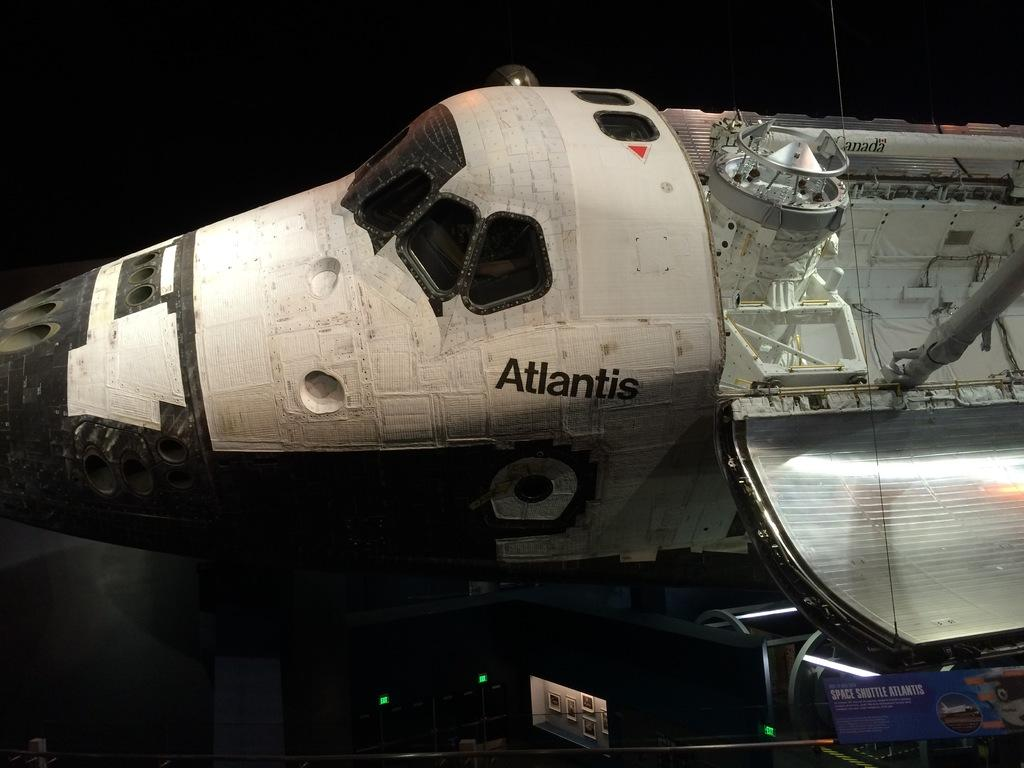<image>
Provide a brief description of the given image. The space shuttle Atlantis has a red arrow near one of the windows on top. 